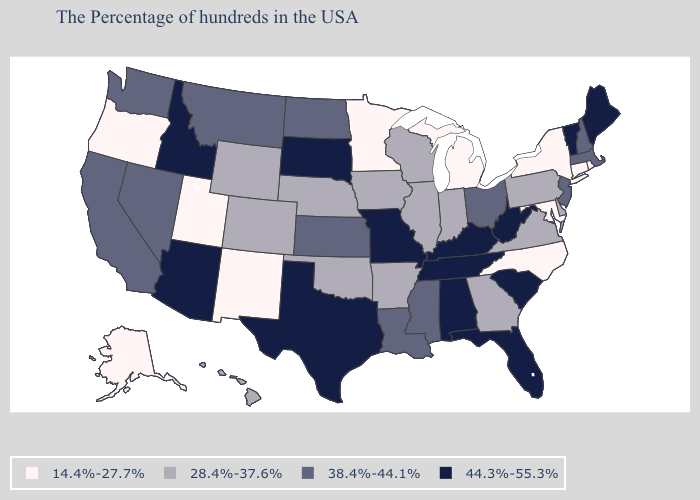Does Michigan have the lowest value in the USA?
Write a very short answer. Yes. What is the value of Georgia?
Give a very brief answer. 28.4%-37.6%. Is the legend a continuous bar?
Give a very brief answer. No. What is the value of Colorado?
Answer briefly. 28.4%-37.6%. Name the states that have a value in the range 44.3%-55.3%?
Quick response, please. Maine, Vermont, South Carolina, West Virginia, Florida, Kentucky, Alabama, Tennessee, Missouri, Texas, South Dakota, Arizona, Idaho. Does the map have missing data?
Keep it brief. No. Which states have the lowest value in the Northeast?
Answer briefly. Rhode Island, Connecticut, New York. What is the highest value in the MidWest ?
Write a very short answer. 44.3%-55.3%. What is the value of Oklahoma?
Be succinct. 28.4%-37.6%. What is the highest value in states that border Georgia?
Write a very short answer. 44.3%-55.3%. What is the highest value in the USA?
Short answer required. 44.3%-55.3%. What is the lowest value in the Northeast?
Concise answer only. 14.4%-27.7%. Name the states that have a value in the range 14.4%-27.7%?
Be succinct. Rhode Island, Connecticut, New York, Maryland, North Carolina, Michigan, Minnesota, New Mexico, Utah, Oregon, Alaska. What is the value of Connecticut?
Short answer required. 14.4%-27.7%. What is the highest value in the West ?
Concise answer only. 44.3%-55.3%. 